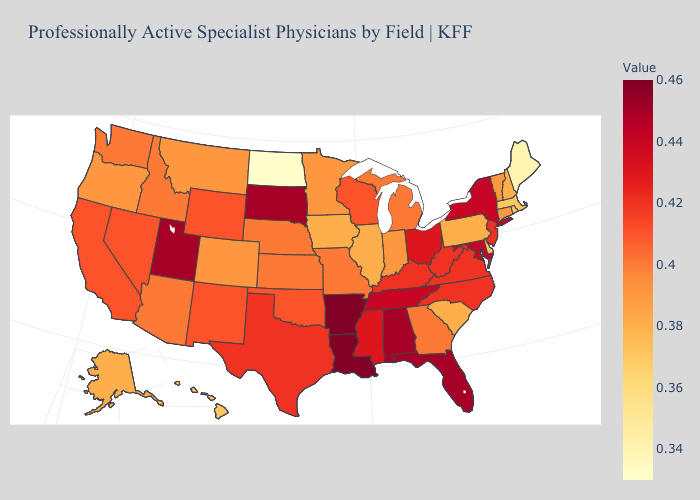Among the states that border New Mexico , does Texas have the lowest value?
Be succinct. No. Is the legend a continuous bar?
Short answer required. Yes. Which states have the lowest value in the USA?
Keep it brief. North Dakota. Among the states that border New York , which have the lowest value?
Concise answer only. Massachusetts. Is the legend a continuous bar?
Keep it brief. Yes. 